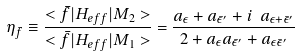Convert formula to latex. <formula><loc_0><loc_0><loc_500><loc_500>\eta _ { \bar { f } } \equiv \frac { < \bar { f } | H _ { e f f } | M _ { 2 } > } { < \bar { f } | H _ { e f f } | M _ { 1 } > } = \frac { a _ { \epsilon } + a _ { \bar { \epsilon } ^ { \prime } } + i \ a _ { \epsilon + \bar { \epsilon } ^ { \prime } } } { 2 + a _ { \epsilon } a _ { \bar { \epsilon } ^ { \prime } } + a _ { \epsilon \bar { \epsilon } ^ { \prime } } }</formula> 